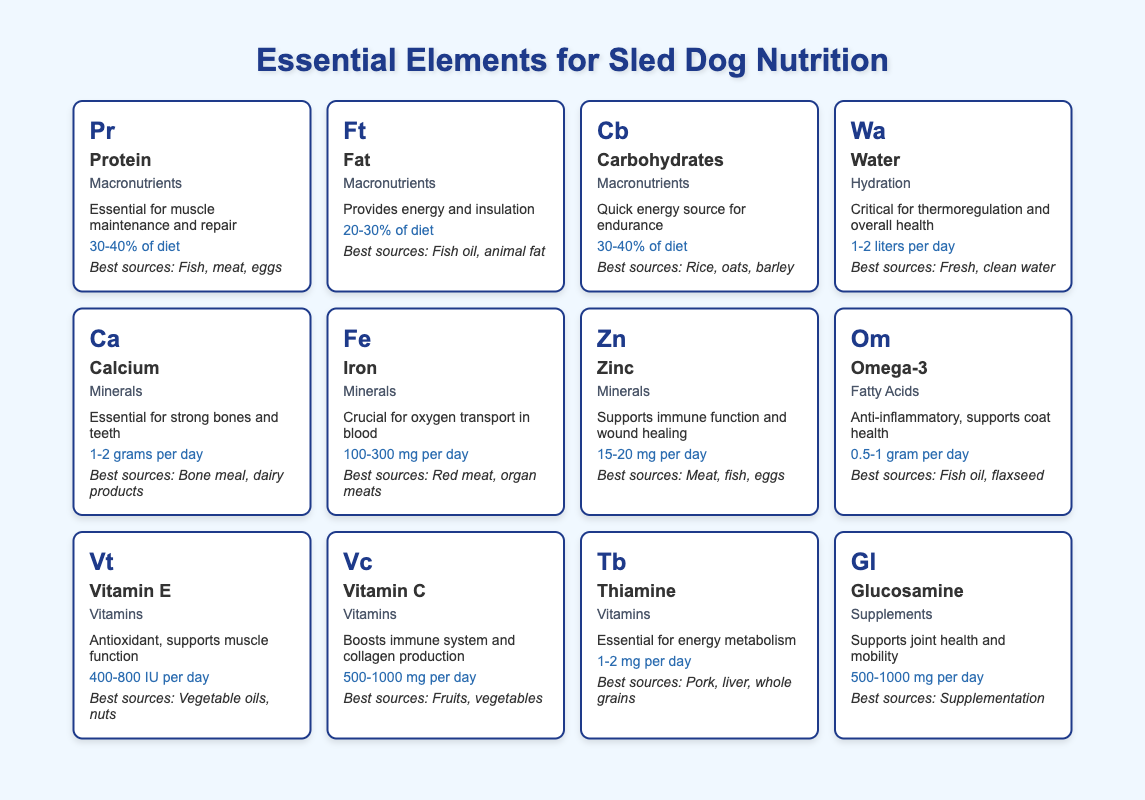What is the daily requirement of Vitamin E? The table shows that the daily requirement for Vitamin E is 400-800 IU per day as listed under the Vitamin E entry.
Answer: 400-800 IU per day Which macronutrient requires the highest percentage of the diet? From the table, both Protein and Carbohydrates have a daily requirement of 30-40%. This is higher than Fat, which requires 20-30%. Therefore, Protein and Carbohydrates share the highest requirement.
Answer: Protein and Carbohydrates (30-40% of diet) Is Omega-3 essential for strong bones? The table describes Omega-3 as anti-inflammatory and supportive of coat health, but does not state it is essential for strong bones. This description makes it clear that it is not directly linked to bone health.
Answer: No What are the best sources of Zinc? The best sources of Zinc according to the table are meat, fish, and eggs, which are clearly listed under the Zinc entry in the table.
Answer: Meat, fish, eggs How do the daily requirements of Vitamin C and Thiamine compare? The table shows that Vitamin C has a daily requirement of 500-1000 mg, while Thiamine requires 1-2 mg per day. To compare, Vitamin C requires significantly more (at least 500 mg compared to 1 mg). Therefore, Vitamin C has a much higher daily requirement than Thiamine.
Answer: Vitamin C requires significantly more than Thiamine What is the combined daily requirement of Calcium and Iron in grams? From the table, Calcium has a daily requirement of 1-2 grams, while Iron's daily requirement is 100-300 mg. Converting Iron to grams, it is 0.1-0.3 grams. Adding the lower limits gives us 1 + 0.1 = 1.1 grams, and the upper limits give us 2 + 0.3 = 2.3 grams. Therefore, the combined requirement ranges from 1.1 to 2.3 grams.
Answer: 1.1 to 2.3 grams Does Water have a role in muscle maintenance? The table describes the role of Water in thermoregulation and overall health but does not mention muscle maintenance explicitly, so we can conclude that it does not have a direct role in muscle maintenance.
Answer: No What percentage of a sled dog’s diet should consist of fat? The table notes that Fat should constitute 20-30% of a sled dog’s diet, specifying the exact percentage required for optimal nutrition.
Answer: 20-30% of diet Which element is listed as essential for joint health? The table states that Glucosamine is identified as supporting joint health and mobility under the Supplements category. Thus, Glucosamine is essential for joint health.
Answer: Glucosamine 